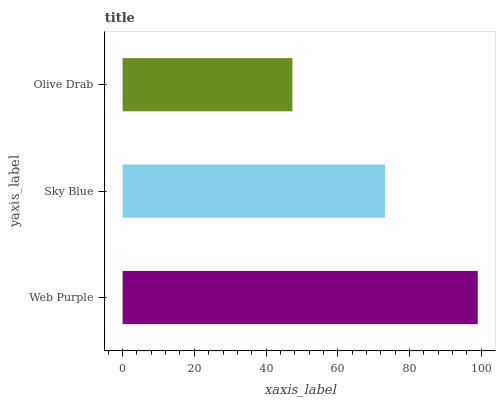Is Olive Drab the minimum?
Answer yes or no. Yes. Is Web Purple the maximum?
Answer yes or no. Yes. Is Sky Blue the minimum?
Answer yes or no. No. Is Sky Blue the maximum?
Answer yes or no. No. Is Web Purple greater than Sky Blue?
Answer yes or no. Yes. Is Sky Blue less than Web Purple?
Answer yes or no. Yes. Is Sky Blue greater than Web Purple?
Answer yes or no. No. Is Web Purple less than Sky Blue?
Answer yes or no. No. Is Sky Blue the high median?
Answer yes or no. Yes. Is Sky Blue the low median?
Answer yes or no. Yes. Is Web Purple the high median?
Answer yes or no. No. Is Olive Drab the low median?
Answer yes or no. No. 